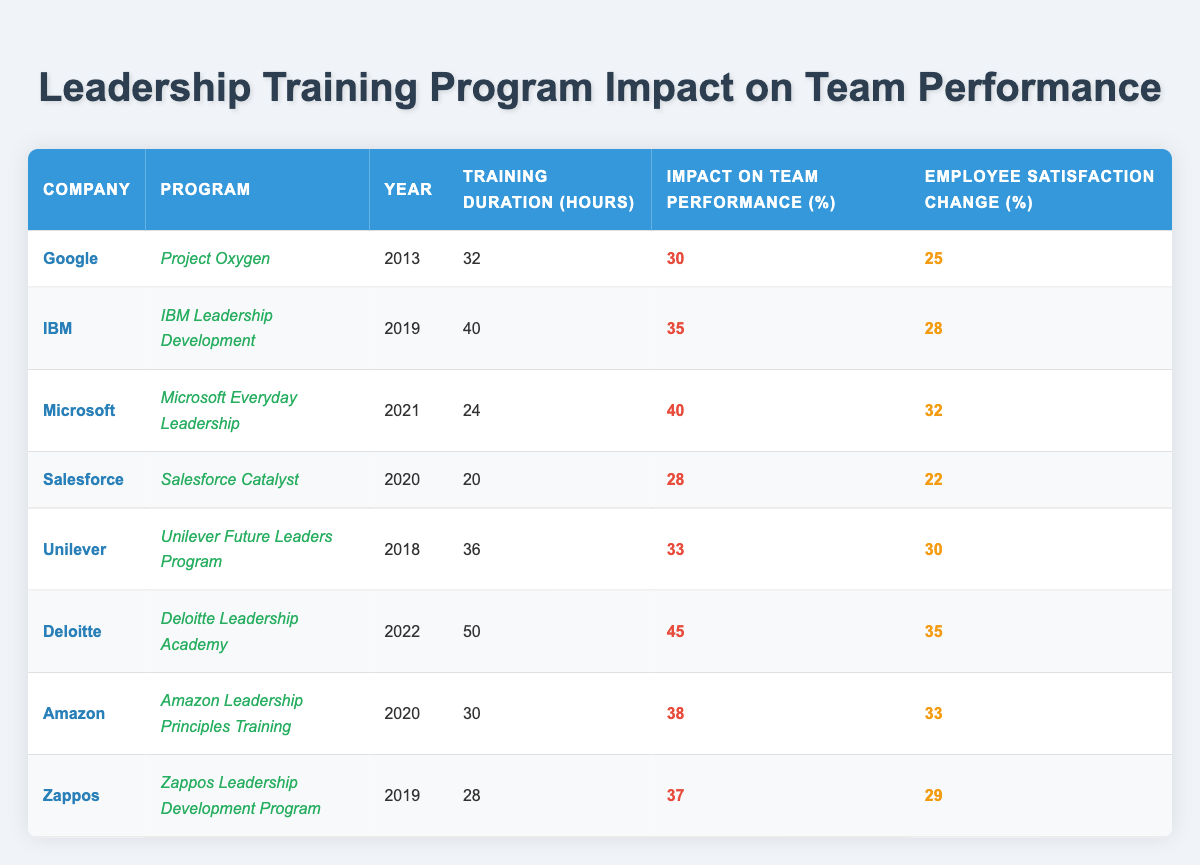What is the training duration of Deloitte's program? The table lists Deloitte's program, "Deloitte Leadership Academy", with a training duration of 50 hours.
Answer: 50 hours Which company had the highest impact on team performance according to the table? According to the table, the program with the highest impact on team performance is Deloitte's, with a 45% impact.
Answer: Deloitte What is the average employee satisfaction change across all programs? To find the average, sum the employee satisfaction changes: (25 + 28 + 32 + 22 + 30 + 35 + 33 + 29) = 264. There are 8 programs, so the average is 264 / 8 = 33.
Answer: 33 Did Amazon's program have a greater impact on team performance than Salesforce's? Amazon's program had a 38% impact, while Salesforce's had a 28% impact. Thus, Amazon's program had a greater impact.
Answer: Yes What was the difference in employee satisfaction change between the highest and lowest performing programs? The highest employee satisfaction change was 35% (Deloitte), while the lowest was 22% (Salesforce). The difference is 35 - 22 = 13%.
Answer: 13% Which company had the lowest training duration and what was that duration? The company with the lowest training duration is Salesforce, which had a duration of 20 hours.
Answer: Salesforce, 20 hours If you rank the programs based on their impact on team performance, what is the impact percentage of the median program? The impact percentages in order are 28%, 30%, 33%, 35%, 37%, 38%, 40%, and 45%. The median (the middle value of the sorted list) is the average of the 4th and 5th values (35% and 37%): (35 + 37) / 2 = 36%.
Answer: 36% Which program had both a training duration of less than 30 hours and an employee satisfaction change greater than 30%? The only program that matches both conditions is Amazon's program, which had 30 hours of training and a 33% employee satisfaction change.
Answer: Amazon What year had the least hours of training across all programs? The program with the least training hours in the table is Salesforce's program, which was in 2020 with 20 hours.
Answer: 2020, 20 hours How many programs had an impact on team performance greater than or equal to 35%? There are four programs with an impact greater than or equal to 35%: IBM, Microsoft, Deloitte, and Zappos, totaling four programs.
Answer: 4 